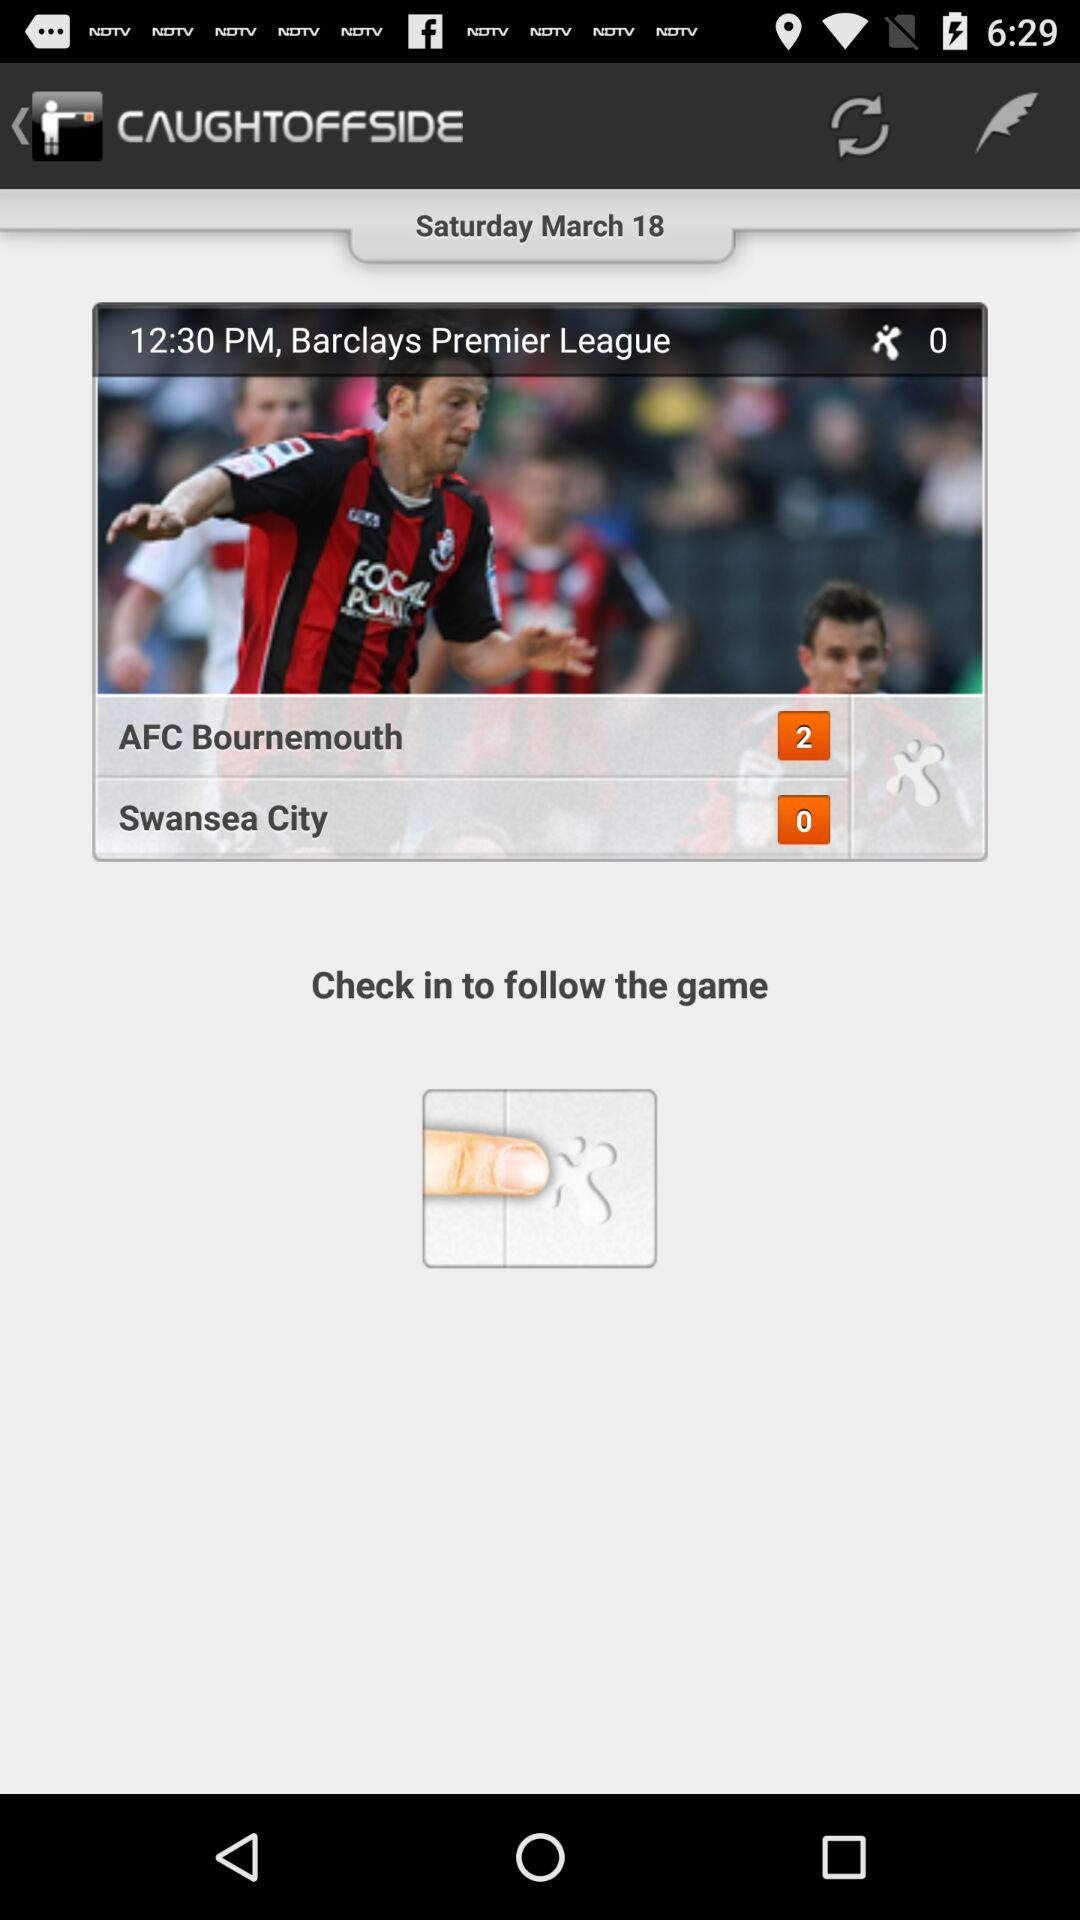For which time is the match scheduled? The match is scheduled for 12:30 PM. 